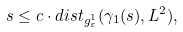Convert formula to latex. <formula><loc_0><loc_0><loc_500><loc_500>s \leq c \cdot d i s t _ { g _ { \varepsilon } ^ { 1 } } ( \gamma _ { 1 } ( s ) , L ^ { 2 } ) ,</formula> 